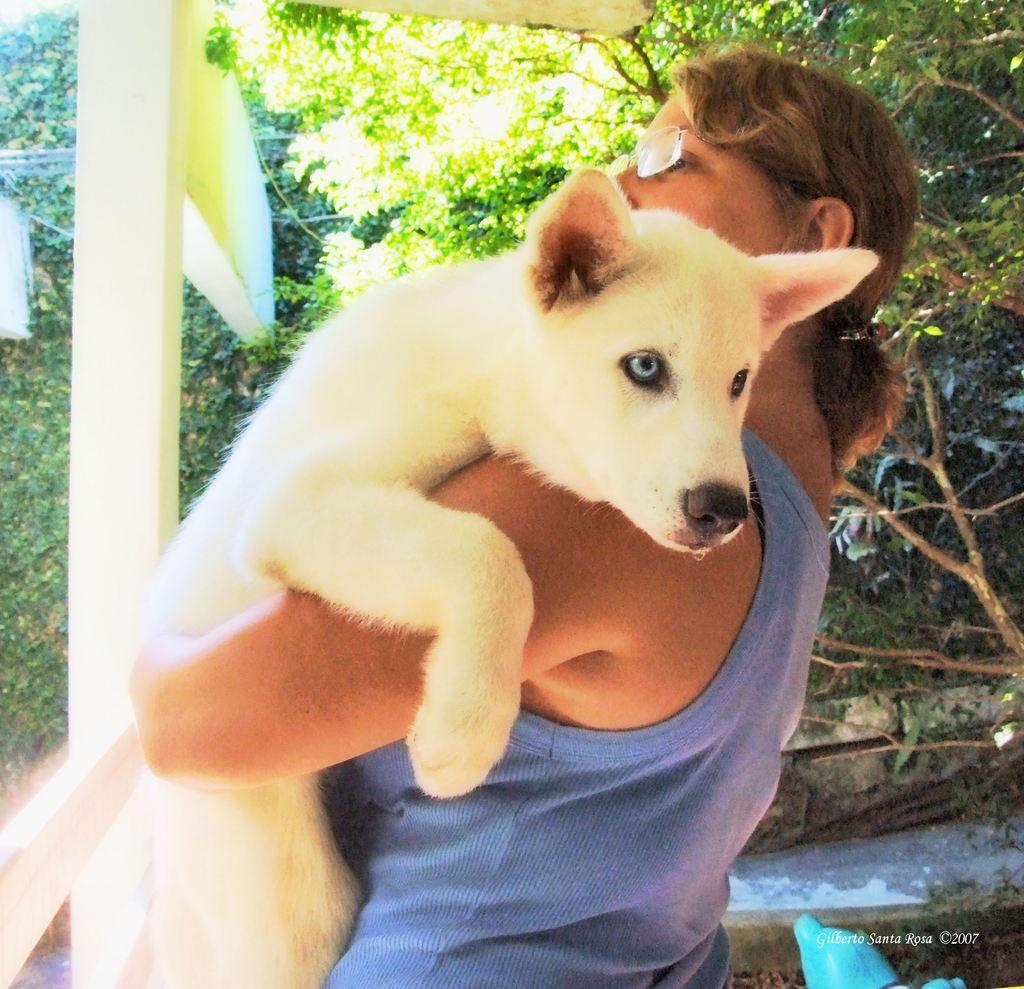What is the main subject of the image? There is a woman standing in the image. What is the woman holding in the image? The woman is holding a white-colored dog. What can be seen in the background of the image? There are trees visible in the background of the image. Can you see the ocean in the background of the image? No, the ocean is not visible in the background of the image; there are trees instead. 